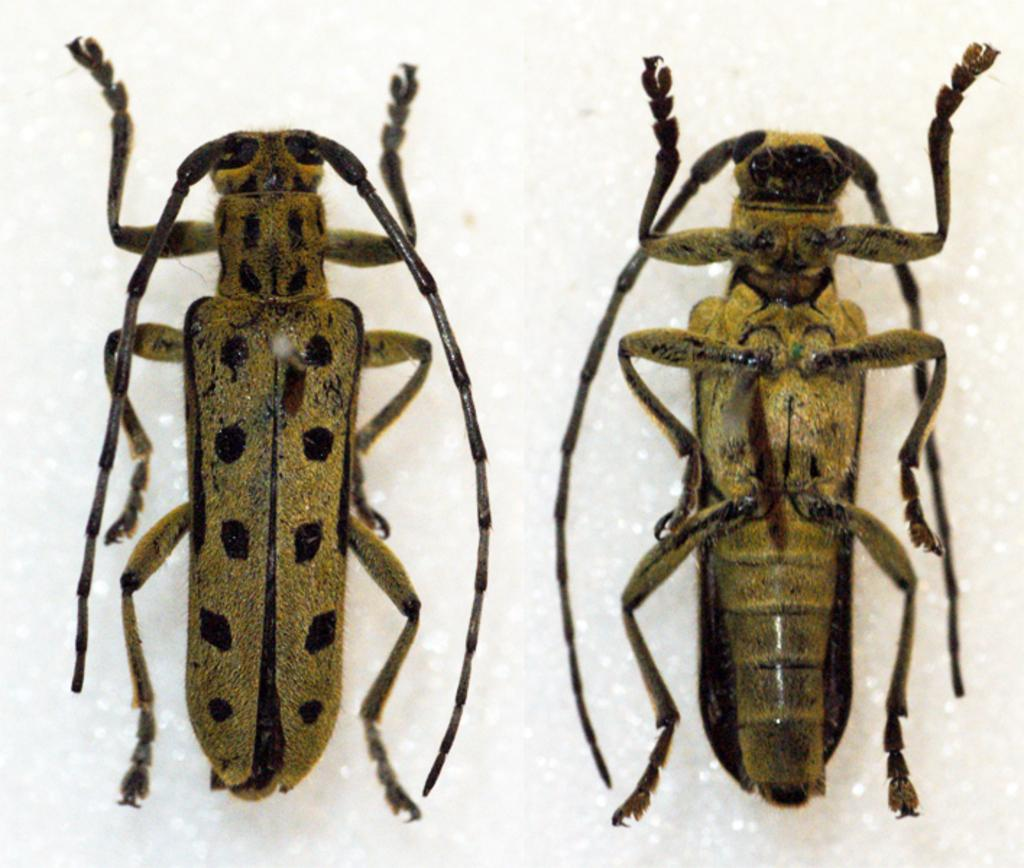What type of creatures are present in the image? There are cockroaches in the image. What color is the background of the image? The background of the image is white. What time is displayed on the map in the image? There is no map present in the image, and therefore no time can be displayed. 